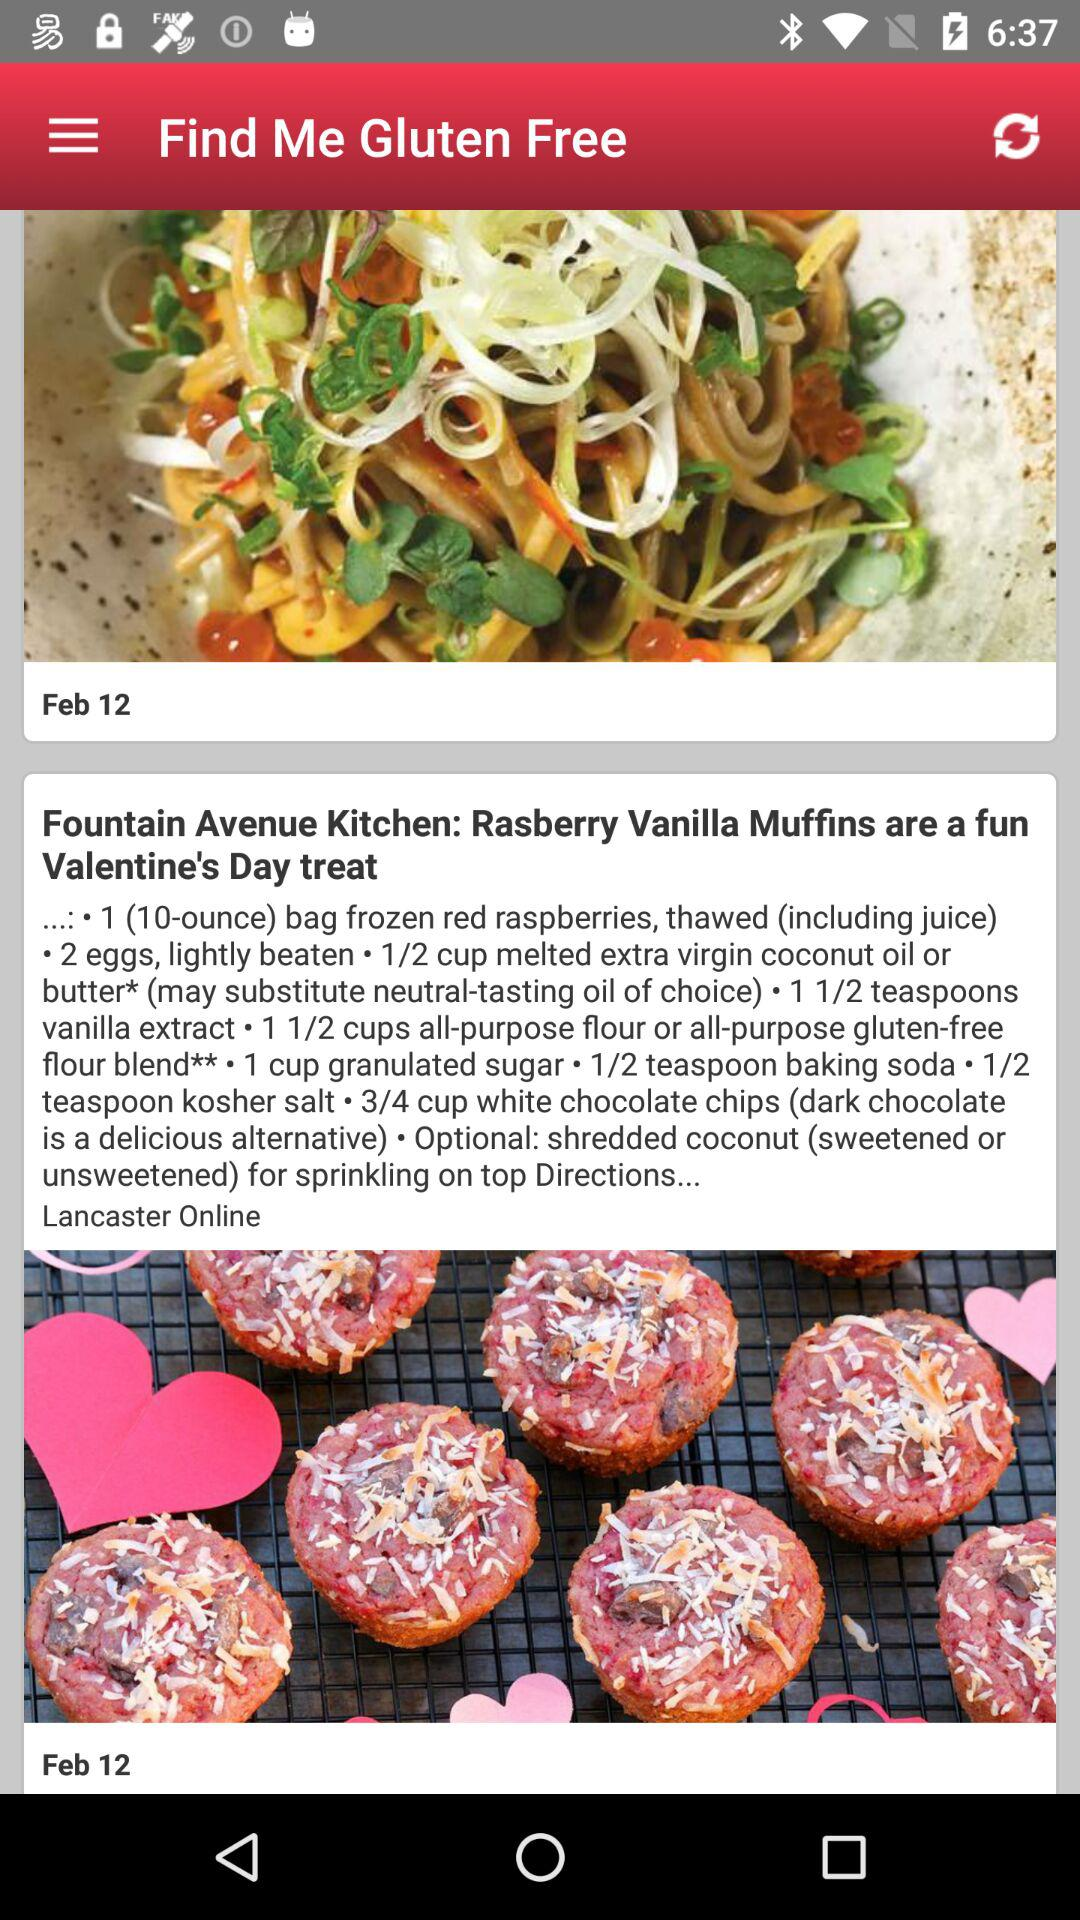How many teaspoons of vanilla extract are needed for the dish? There are one and a half teaspoons of vanilla extract needed for the dish. 